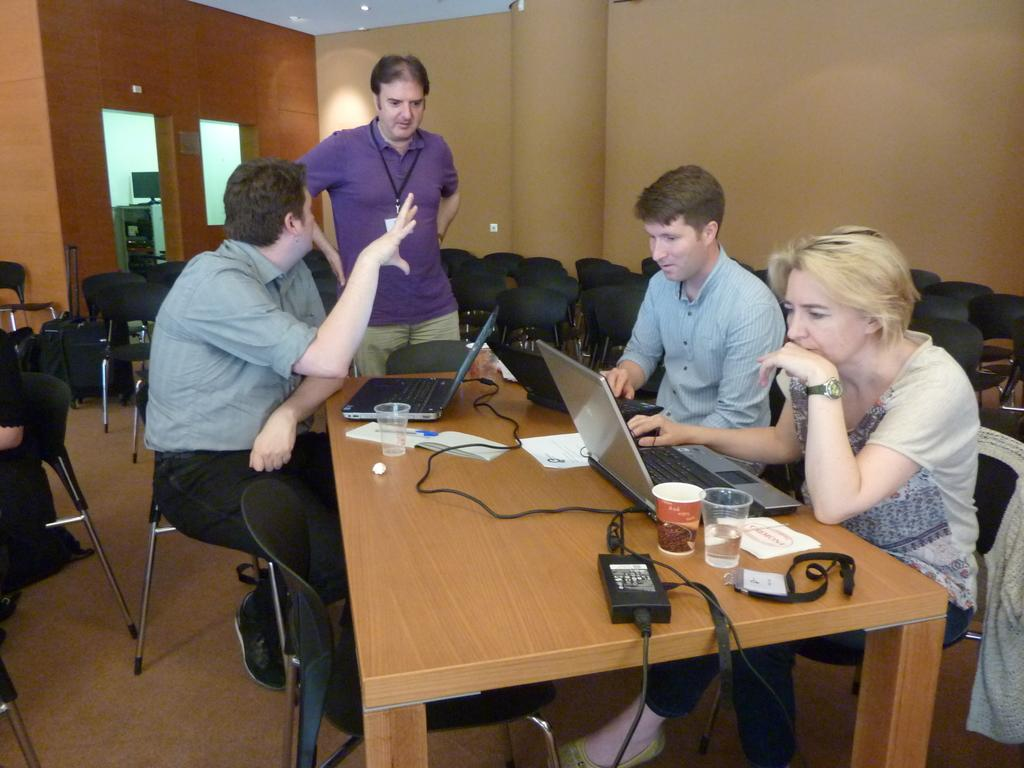How many people are seated in the image? There are three people seated on chairs in the image. What is the position of the fourth person in the image? There is a person standing in the image. What electronic devices are present on the table in the image? There are three laptops on the table in the image. What might the people be using the glasses for in the image? There are at least two glasses on the table in the image, which might be used for drinking. What type of wave can be seen in the image? There is no wave present in the image; it features people seated and standing around a table with laptops and glasses. 